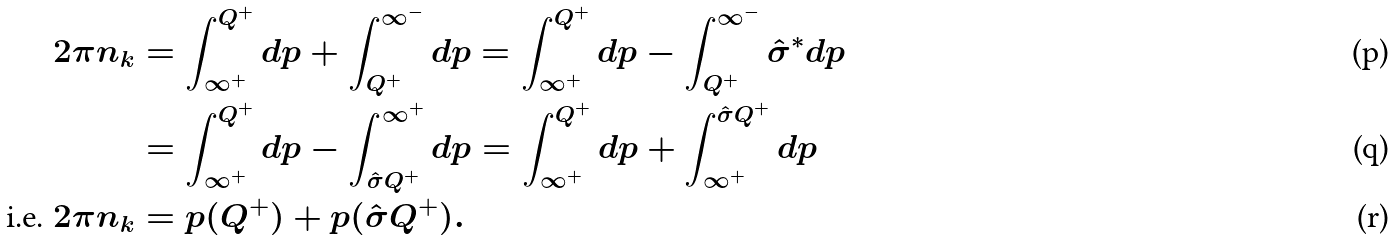Convert formula to latex. <formula><loc_0><loc_0><loc_500><loc_500>2 \pi n _ { k } & = \int _ { \infty ^ { + } } ^ { Q ^ { + } } d p + \int _ { Q ^ { + } } ^ { \infty ^ { - } } d p = \int _ { \infty ^ { + } } ^ { Q ^ { + } } d p - \int _ { Q ^ { + } } ^ { \infty ^ { - } } \hat { \sigma } ^ { \ast } d p \\ & = \int _ { \infty ^ { + } } ^ { Q ^ { + } } d p - \int _ { \hat { \sigma } Q ^ { + } } ^ { \infty ^ { + } } d p = \int _ { \infty ^ { + } } ^ { Q ^ { + } } d p + \int _ { \infty ^ { + } } ^ { \hat { \sigma } Q ^ { + } } d p \\ \text {i.e. } 2 \pi n _ { k } & = p ( Q ^ { + } ) + p ( \hat { \sigma } Q ^ { + } ) .</formula> 